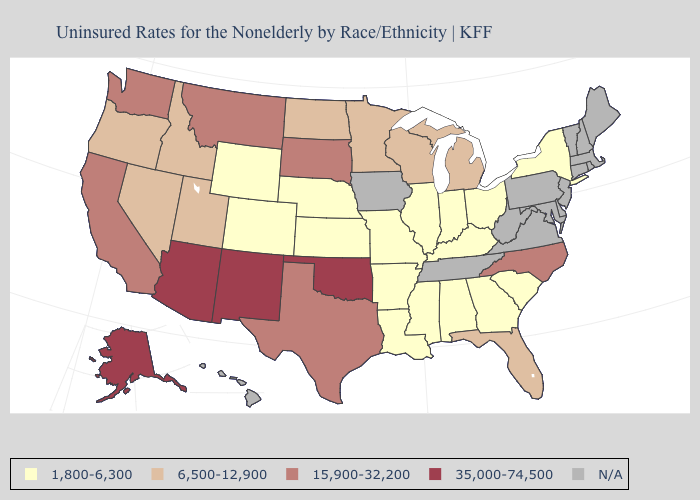Does New Mexico have the highest value in the USA?
Give a very brief answer. Yes. Among the states that border South Dakota , which have the lowest value?
Concise answer only. Nebraska, Wyoming. Among the states that border Michigan , does Wisconsin have the highest value?
Be succinct. Yes. What is the highest value in states that border West Virginia?
Answer briefly. 1,800-6,300. What is the highest value in the USA?
Answer briefly. 35,000-74,500. Among the states that border Arizona , does Colorado have the lowest value?
Be succinct. Yes. What is the value of Delaware?
Short answer required. N/A. Name the states that have a value in the range 15,900-32,200?
Concise answer only. California, Montana, North Carolina, South Dakota, Texas, Washington. Which states have the highest value in the USA?
Write a very short answer. Alaska, Arizona, New Mexico, Oklahoma. What is the value of West Virginia?
Give a very brief answer. N/A. Name the states that have a value in the range 15,900-32,200?
Quick response, please. California, Montana, North Carolina, South Dakota, Texas, Washington. What is the lowest value in states that border Arizona?
Short answer required. 1,800-6,300. 